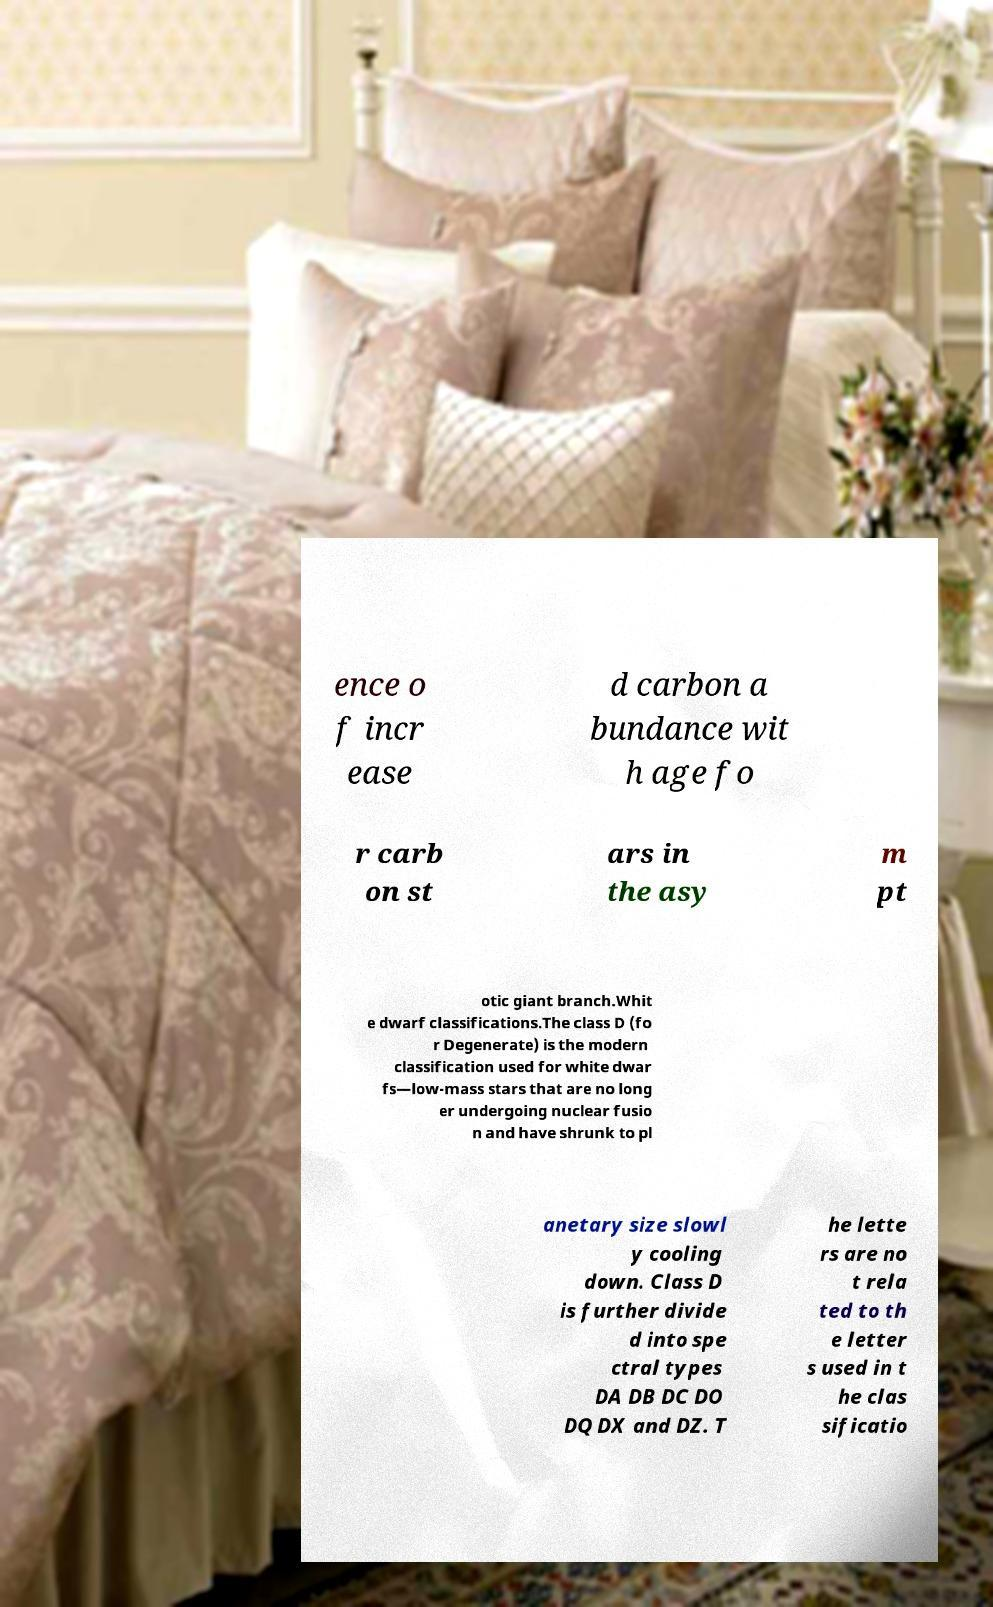What messages or text are displayed in this image? I need them in a readable, typed format. ence o f incr ease d carbon a bundance wit h age fo r carb on st ars in the asy m pt otic giant branch.Whit e dwarf classifications.The class D (fo r Degenerate) is the modern classification used for white dwar fs—low-mass stars that are no long er undergoing nuclear fusio n and have shrunk to pl anetary size slowl y cooling down. Class D is further divide d into spe ctral types DA DB DC DO DQ DX and DZ. T he lette rs are no t rela ted to th e letter s used in t he clas sificatio 